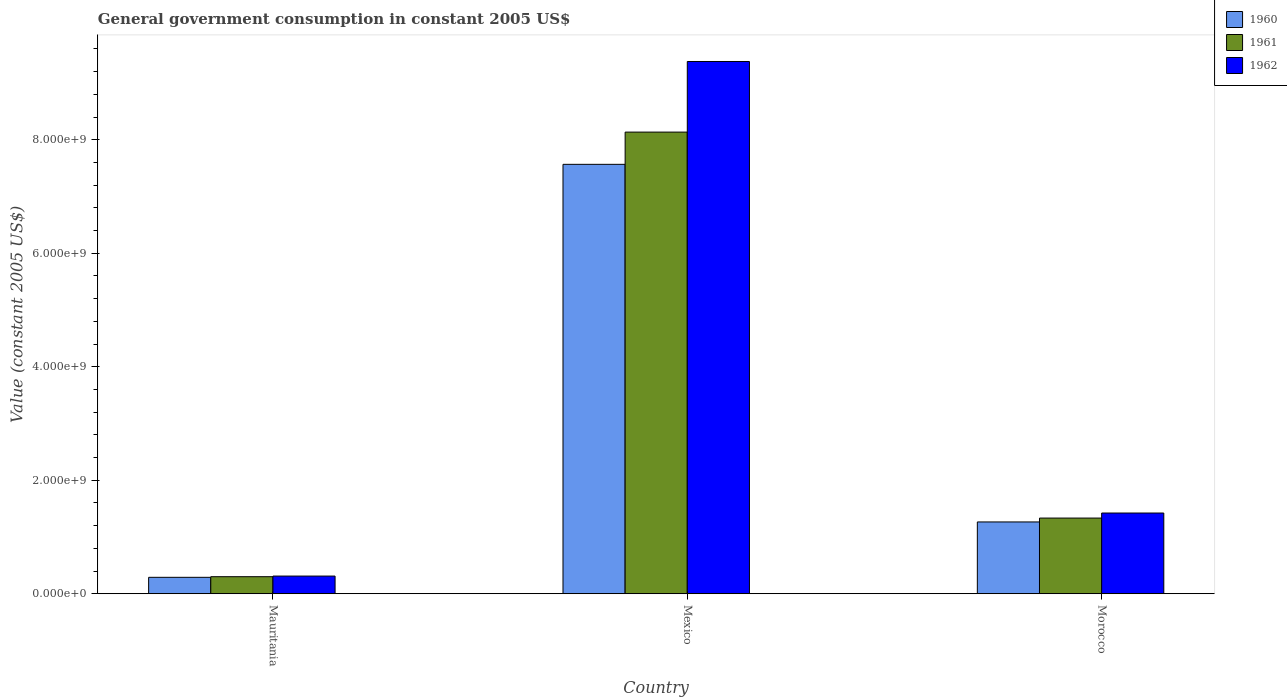How many groups of bars are there?
Keep it short and to the point. 3. Are the number of bars per tick equal to the number of legend labels?
Keep it short and to the point. Yes. What is the label of the 3rd group of bars from the left?
Your response must be concise. Morocco. In how many cases, is the number of bars for a given country not equal to the number of legend labels?
Offer a very short reply. 0. What is the government conusmption in 1962 in Morocco?
Provide a short and direct response. 1.42e+09. Across all countries, what is the maximum government conusmption in 1961?
Provide a succinct answer. 8.13e+09. Across all countries, what is the minimum government conusmption in 1960?
Make the answer very short. 2.89e+08. In which country was the government conusmption in 1962 minimum?
Your answer should be very brief. Mauritania. What is the total government conusmption in 1961 in the graph?
Keep it short and to the point. 9.77e+09. What is the difference between the government conusmption in 1961 in Mexico and that in Morocco?
Keep it short and to the point. 6.80e+09. What is the difference between the government conusmption in 1961 in Mexico and the government conusmption in 1960 in Morocco?
Keep it short and to the point. 6.87e+09. What is the average government conusmption in 1961 per country?
Make the answer very short. 3.26e+09. What is the difference between the government conusmption of/in 1961 and government conusmption of/in 1962 in Mexico?
Keep it short and to the point. -1.24e+09. What is the ratio of the government conusmption in 1961 in Mauritania to that in Mexico?
Ensure brevity in your answer.  0.04. Is the difference between the government conusmption in 1961 in Mexico and Morocco greater than the difference between the government conusmption in 1962 in Mexico and Morocco?
Offer a terse response. No. What is the difference between the highest and the second highest government conusmption in 1961?
Make the answer very short. 7.83e+09. What is the difference between the highest and the lowest government conusmption in 1962?
Provide a short and direct response. 9.07e+09. In how many countries, is the government conusmption in 1962 greater than the average government conusmption in 1962 taken over all countries?
Keep it short and to the point. 1. What does the 3rd bar from the left in Mexico represents?
Give a very brief answer. 1962. What does the 3rd bar from the right in Morocco represents?
Provide a succinct answer. 1960. Is it the case that in every country, the sum of the government conusmption in 1961 and government conusmption in 1960 is greater than the government conusmption in 1962?
Your answer should be compact. Yes. How many bars are there?
Give a very brief answer. 9. What is the difference between two consecutive major ticks on the Y-axis?
Provide a succinct answer. 2.00e+09. Are the values on the major ticks of Y-axis written in scientific E-notation?
Keep it short and to the point. Yes. Does the graph contain grids?
Offer a very short reply. No. Where does the legend appear in the graph?
Offer a terse response. Top right. How many legend labels are there?
Your response must be concise. 3. What is the title of the graph?
Give a very brief answer. General government consumption in constant 2005 US$. Does "1973" appear as one of the legend labels in the graph?
Keep it short and to the point. No. What is the label or title of the Y-axis?
Offer a very short reply. Value (constant 2005 US$). What is the Value (constant 2005 US$) in 1960 in Mauritania?
Provide a succinct answer. 2.89e+08. What is the Value (constant 2005 US$) of 1961 in Mauritania?
Ensure brevity in your answer.  3.00e+08. What is the Value (constant 2005 US$) of 1962 in Mauritania?
Make the answer very short. 3.11e+08. What is the Value (constant 2005 US$) in 1960 in Mexico?
Your answer should be very brief. 7.57e+09. What is the Value (constant 2005 US$) in 1961 in Mexico?
Provide a short and direct response. 8.13e+09. What is the Value (constant 2005 US$) of 1962 in Mexico?
Give a very brief answer. 9.38e+09. What is the Value (constant 2005 US$) in 1960 in Morocco?
Keep it short and to the point. 1.27e+09. What is the Value (constant 2005 US$) in 1961 in Morocco?
Offer a terse response. 1.33e+09. What is the Value (constant 2005 US$) in 1962 in Morocco?
Offer a very short reply. 1.42e+09. Across all countries, what is the maximum Value (constant 2005 US$) in 1960?
Your answer should be very brief. 7.57e+09. Across all countries, what is the maximum Value (constant 2005 US$) of 1961?
Keep it short and to the point. 8.13e+09. Across all countries, what is the maximum Value (constant 2005 US$) of 1962?
Offer a terse response. 9.38e+09. Across all countries, what is the minimum Value (constant 2005 US$) in 1960?
Offer a very short reply. 2.89e+08. Across all countries, what is the minimum Value (constant 2005 US$) in 1961?
Ensure brevity in your answer.  3.00e+08. Across all countries, what is the minimum Value (constant 2005 US$) in 1962?
Provide a succinct answer. 3.11e+08. What is the total Value (constant 2005 US$) in 1960 in the graph?
Make the answer very short. 9.12e+09. What is the total Value (constant 2005 US$) of 1961 in the graph?
Your answer should be very brief. 9.77e+09. What is the total Value (constant 2005 US$) in 1962 in the graph?
Give a very brief answer. 1.11e+1. What is the difference between the Value (constant 2005 US$) of 1960 in Mauritania and that in Mexico?
Offer a terse response. -7.28e+09. What is the difference between the Value (constant 2005 US$) in 1961 in Mauritania and that in Mexico?
Ensure brevity in your answer.  -7.83e+09. What is the difference between the Value (constant 2005 US$) of 1962 in Mauritania and that in Mexico?
Provide a short and direct response. -9.07e+09. What is the difference between the Value (constant 2005 US$) of 1960 in Mauritania and that in Morocco?
Offer a terse response. -9.76e+08. What is the difference between the Value (constant 2005 US$) in 1961 in Mauritania and that in Morocco?
Ensure brevity in your answer.  -1.03e+09. What is the difference between the Value (constant 2005 US$) of 1962 in Mauritania and that in Morocco?
Give a very brief answer. -1.11e+09. What is the difference between the Value (constant 2005 US$) of 1960 in Mexico and that in Morocco?
Offer a very short reply. 6.30e+09. What is the difference between the Value (constant 2005 US$) of 1961 in Mexico and that in Morocco?
Provide a succinct answer. 6.80e+09. What is the difference between the Value (constant 2005 US$) of 1962 in Mexico and that in Morocco?
Your answer should be compact. 7.96e+09. What is the difference between the Value (constant 2005 US$) in 1960 in Mauritania and the Value (constant 2005 US$) in 1961 in Mexico?
Offer a terse response. -7.85e+09. What is the difference between the Value (constant 2005 US$) in 1960 in Mauritania and the Value (constant 2005 US$) in 1962 in Mexico?
Offer a very short reply. -9.09e+09. What is the difference between the Value (constant 2005 US$) of 1961 in Mauritania and the Value (constant 2005 US$) of 1962 in Mexico?
Offer a very short reply. -9.08e+09. What is the difference between the Value (constant 2005 US$) of 1960 in Mauritania and the Value (constant 2005 US$) of 1961 in Morocco?
Your answer should be very brief. -1.04e+09. What is the difference between the Value (constant 2005 US$) of 1960 in Mauritania and the Value (constant 2005 US$) of 1962 in Morocco?
Keep it short and to the point. -1.13e+09. What is the difference between the Value (constant 2005 US$) in 1961 in Mauritania and the Value (constant 2005 US$) in 1962 in Morocco?
Give a very brief answer. -1.12e+09. What is the difference between the Value (constant 2005 US$) in 1960 in Mexico and the Value (constant 2005 US$) in 1961 in Morocco?
Give a very brief answer. 6.23e+09. What is the difference between the Value (constant 2005 US$) of 1960 in Mexico and the Value (constant 2005 US$) of 1962 in Morocco?
Your response must be concise. 6.14e+09. What is the difference between the Value (constant 2005 US$) of 1961 in Mexico and the Value (constant 2005 US$) of 1962 in Morocco?
Your answer should be compact. 6.71e+09. What is the average Value (constant 2005 US$) in 1960 per country?
Offer a very short reply. 3.04e+09. What is the average Value (constant 2005 US$) in 1961 per country?
Ensure brevity in your answer.  3.26e+09. What is the average Value (constant 2005 US$) of 1962 per country?
Offer a terse response. 3.70e+09. What is the difference between the Value (constant 2005 US$) in 1960 and Value (constant 2005 US$) in 1961 in Mauritania?
Your answer should be compact. -1.09e+07. What is the difference between the Value (constant 2005 US$) of 1960 and Value (constant 2005 US$) of 1962 in Mauritania?
Your response must be concise. -2.18e+07. What is the difference between the Value (constant 2005 US$) of 1961 and Value (constant 2005 US$) of 1962 in Mauritania?
Your answer should be very brief. -1.09e+07. What is the difference between the Value (constant 2005 US$) of 1960 and Value (constant 2005 US$) of 1961 in Mexico?
Ensure brevity in your answer.  -5.68e+08. What is the difference between the Value (constant 2005 US$) in 1960 and Value (constant 2005 US$) in 1962 in Mexico?
Keep it short and to the point. -1.81e+09. What is the difference between the Value (constant 2005 US$) of 1961 and Value (constant 2005 US$) of 1962 in Mexico?
Ensure brevity in your answer.  -1.24e+09. What is the difference between the Value (constant 2005 US$) in 1960 and Value (constant 2005 US$) in 1961 in Morocco?
Provide a short and direct response. -6.82e+07. What is the difference between the Value (constant 2005 US$) in 1960 and Value (constant 2005 US$) in 1962 in Morocco?
Your answer should be very brief. -1.57e+08. What is the difference between the Value (constant 2005 US$) in 1961 and Value (constant 2005 US$) in 1962 in Morocco?
Your answer should be very brief. -8.90e+07. What is the ratio of the Value (constant 2005 US$) of 1960 in Mauritania to that in Mexico?
Make the answer very short. 0.04. What is the ratio of the Value (constant 2005 US$) in 1961 in Mauritania to that in Mexico?
Your answer should be very brief. 0.04. What is the ratio of the Value (constant 2005 US$) in 1962 in Mauritania to that in Mexico?
Provide a short and direct response. 0.03. What is the ratio of the Value (constant 2005 US$) in 1960 in Mauritania to that in Morocco?
Make the answer very short. 0.23. What is the ratio of the Value (constant 2005 US$) in 1961 in Mauritania to that in Morocco?
Offer a terse response. 0.23. What is the ratio of the Value (constant 2005 US$) in 1962 in Mauritania to that in Morocco?
Your response must be concise. 0.22. What is the ratio of the Value (constant 2005 US$) of 1960 in Mexico to that in Morocco?
Your response must be concise. 5.98. What is the ratio of the Value (constant 2005 US$) in 1961 in Mexico to that in Morocco?
Your response must be concise. 6.1. What is the ratio of the Value (constant 2005 US$) in 1962 in Mexico to that in Morocco?
Your response must be concise. 6.59. What is the difference between the highest and the second highest Value (constant 2005 US$) in 1960?
Ensure brevity in your answer.  6.30e+09. What is the difference between the highest and the second highest Value (constant 2005 US$) in 1961?
Your answer should be compact. 6.80e+09. What is the difference between the highest and the second highest Value (constant 2005 US$) of 1962?
Your answer should be very brief. 7.96e+09. What is the difference between the highest and the lowest Value (constant 2005 US$) in 1960?
Offer a terse response. 7.28e+09. What is the difference between the highest and the lowest Value (constant 2005 US$) in 1961?
Offer a terse response. 7.83e+09. What is the difference between the highest and the lowest Value (constant 2005 US$) of 1962?
Offer a terse response. 9.07e+09. 